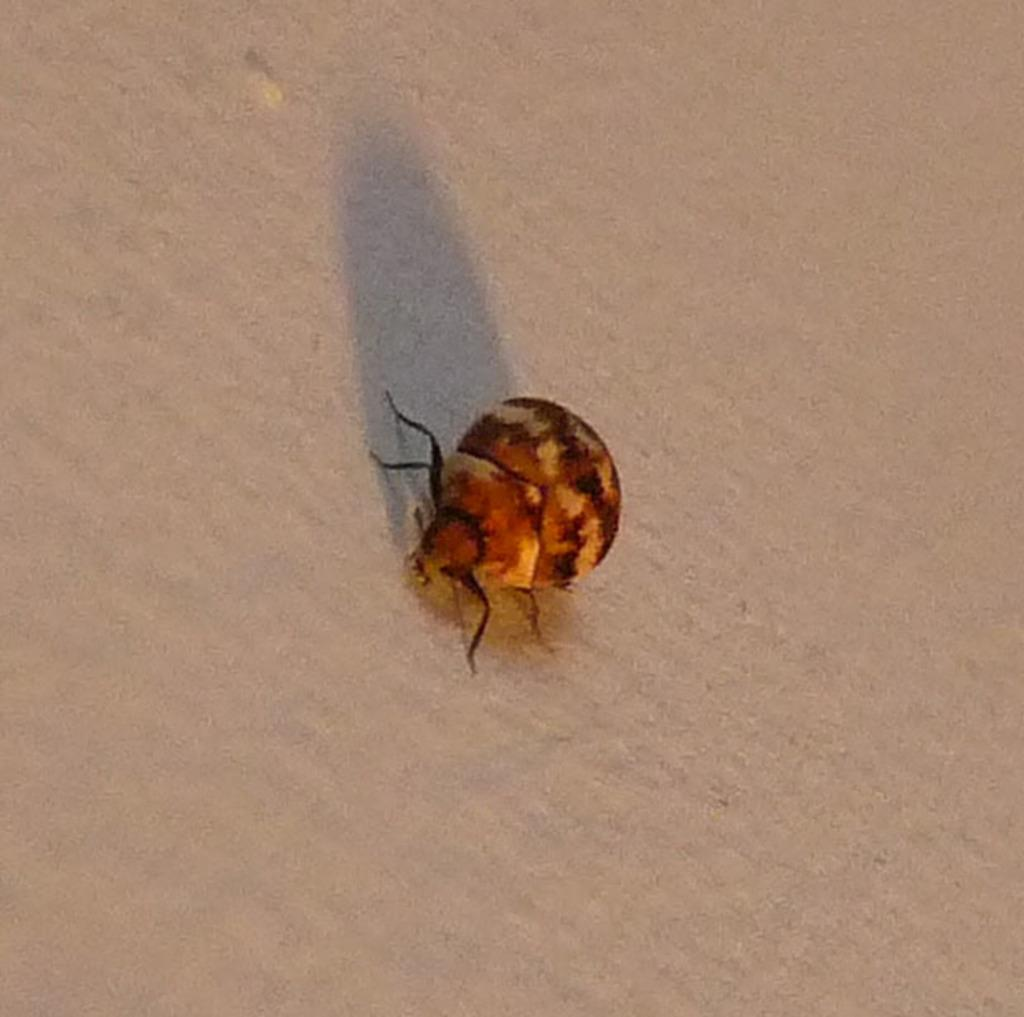What is present on the wall in the image? There is an insect in the image. Can you describe the insect's appearance? The insect has black and brown coloring. What type of silk is being produced by the insect in the image? There is no indication in the image that the insect is producing silk. 